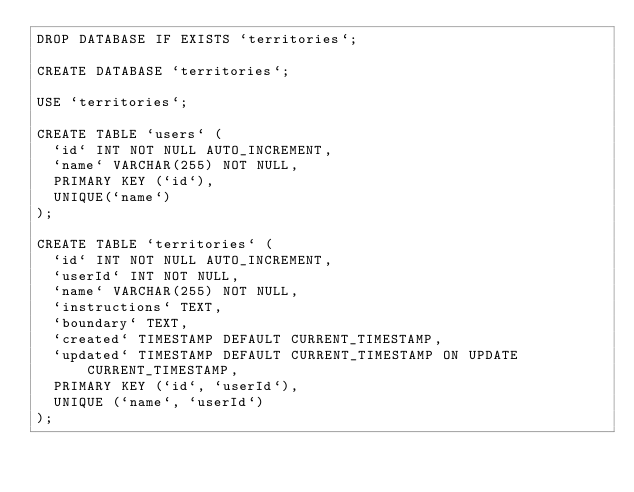<code> <loc_0><loc_0><loc_500><loc_500><_SQL_>DROP DATABASE IF EXISTS `territories`;

CREATE DATABASE `territories`;

USE `territories`;

CREATE TABLE `users` (
  `id` INT NOT NULL AUTO_INCREMENT,
  `name` VARCHAR(255) NOT NULL,
  PRIMARY KEY (`id`),
  UNIQUE(`name`)
);

CREATE TABLE `territories` (
  `id` INT NOT NULL AUTO_INCREMENT,
  `userId` INT NOT NULL,
  `name` VARCHAR(255) NOT NULL,
  `instructions` TEXT,
  `boundary` TEXT,
  `created` TIMESTAMP DEFAULT CURRENT_TIMESTAMP,
  `updated` TIMESTAMP DEFAULT CURRENT_TIMESTAMP ON UPDATE CURRENT_TIMESTAMP,
  PRIMARY KEY (`id`, `userId`),
  UNIQUE (`name`, `userId`)
);
</code> 